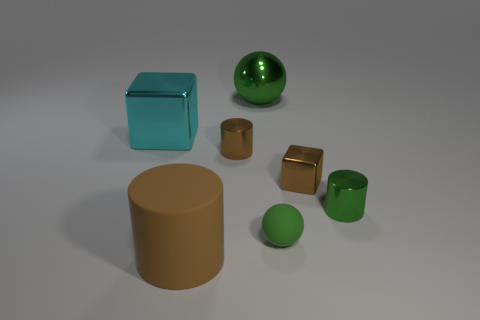Is the number of large metallic objects greater than the number of big objects?
Make the answer very short. No. Does the matte thing that is behind the large brown matte cylinder have the same color as the cylinder that is on the right side of the tiny ball?
Your answer should be very brief. Yes. There is a small shiny cylinder behind the tiny green metal object; is there a metal thing that is on the left side of it?
Your answer should be very brief. Yes. Is the number of blocks in front of the small green sphere less than the number of metallic objects in front of the cyan shiny thing?
Offer a very short reply. Yes. Is the brown cylinder that is behind the big brown cylinder made of the same material as the tiny cylinder to the right of the small brown metallic cylinder?
Ensure brevity in your answer.  Yes. How many big things are either green matte balls or matte objects?
Offer a very short reply. 1. There is a small green thing that is made of the same material as the tiny brown cylinder; what shape is it?
Offer a terse response. Cylinder. Is the number of large brown matte things on the right side of the big metallic sphere less than the number of cyan cubes?
Provide a short and direct response. Yes. Does the green matte object have the same shape as the big green metal thing?
Your answer should be compact. Yes. What number of shiny things are either cyan cubes or brown cubes?
Offer a terse response. 2. 